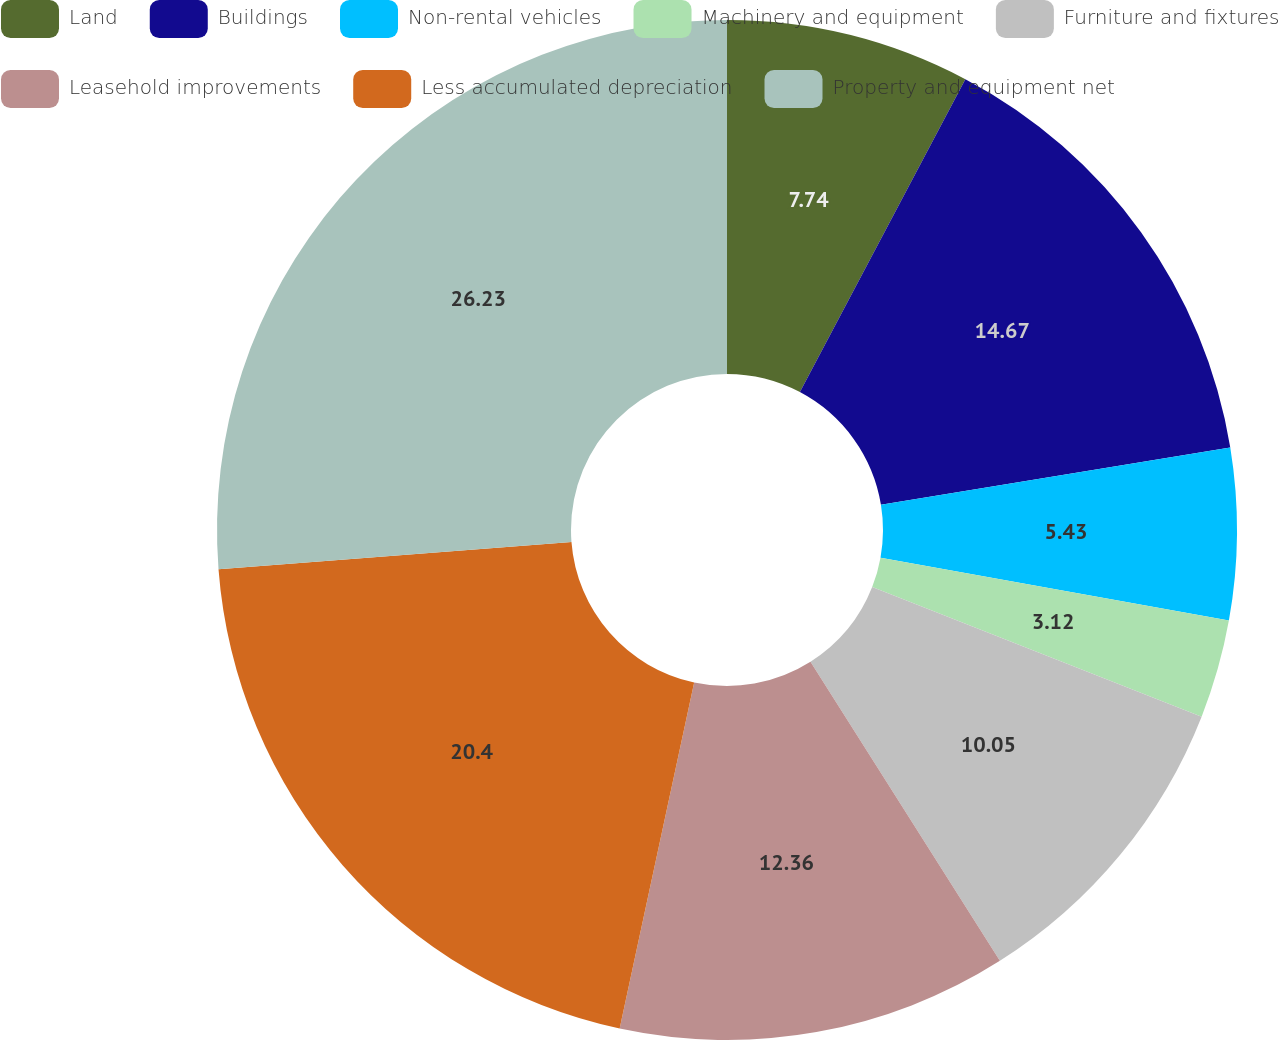Convert chart. <chart><loc_0><loc_0><loc_500><loc_500><pie_chart><fcel>Land<fcel>Buildings<fcel>Non-rental vehicles<fcel>Machinery and equipment<fcel>Furniture and fixtures<fcel>Leasehold improvements<fcel>Less accumulated depreciation<fcel>Property and equipment net<nl><fcel>7.74%<fcel>14.67%<fcel>5.43%<fcel>3.12%<fcel>10.05%<fcel>12.36%<fcel>20.4%<fcel>26.22%<nl></chart> 